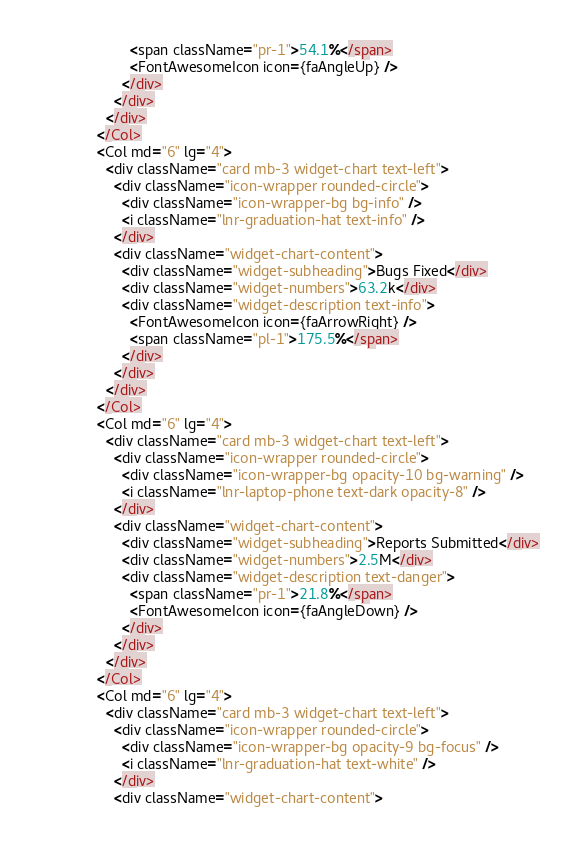Convert code to text. <code><loc_0><loc_0><loc_500><loc_500><_JavaScript_>                      <span className="pr-1">54.1%</span>
                      <FontAwesomeIcon icon={faAngleUp} />
                    </div>
                  </div>
                </div>
              </Col>
              <Col md="6" lg="4">
                <div className="card mb-3 widget-chart text-left">
                  <div className="icon-wrapper rounded-circle">
                    <div className="icon-wrapper-bg bg-info" />
                    <i className="lnr-graduation-hat text-info" />
                  </div>
                  <div className="widget-chart-content">
                    <div className="widget-subheading">Bugs Fixed</div>
                    <div className="widget-numbers">63.2k</div>
                    <div className="widget-description text-info">
                      <FontAwesomeIcon icon={faArrowRight} />
                      <span className="pl-1">175.5%</span>
                    </div>
                  </div>
                </div>
              </Col>
              <Col md="6" lg="4">
                <div className="card mb-3 widget-chart text-left">
                  <div className="icon-wrapper rounded-circle">
                    <div className="icon-wrapper-bg opacity-10 bg-warning" />
                    <i className="lnr-laptop-phone text-dark opacity-8" />
                  </div>
                  <div className="widget-chart-content">
                    <div className="widget-subheading">Reports Submitted</div>
                    <div className="widget-numbers">2.5M</div>
                    <div className="widget-description text-danger">
                      <span className="pr-1">21.8%</span>
                      <FontAwesomeIcon icon={faAngleDown} />
                    </div>
                  </div>
                </div>
              </Col>
              <Col md="6" lg="4">
                <div className="card mb-3 widget-chart text-left">
                  <div className="icon-wrapper rounded-circle">
                    <div className="icon-wrapper-bg opacity-9 bg-focus" />
                    <i className="lnr-graduation-hat text-white" />
                  </div>
                  <div className="widget-chart-content"></code> 